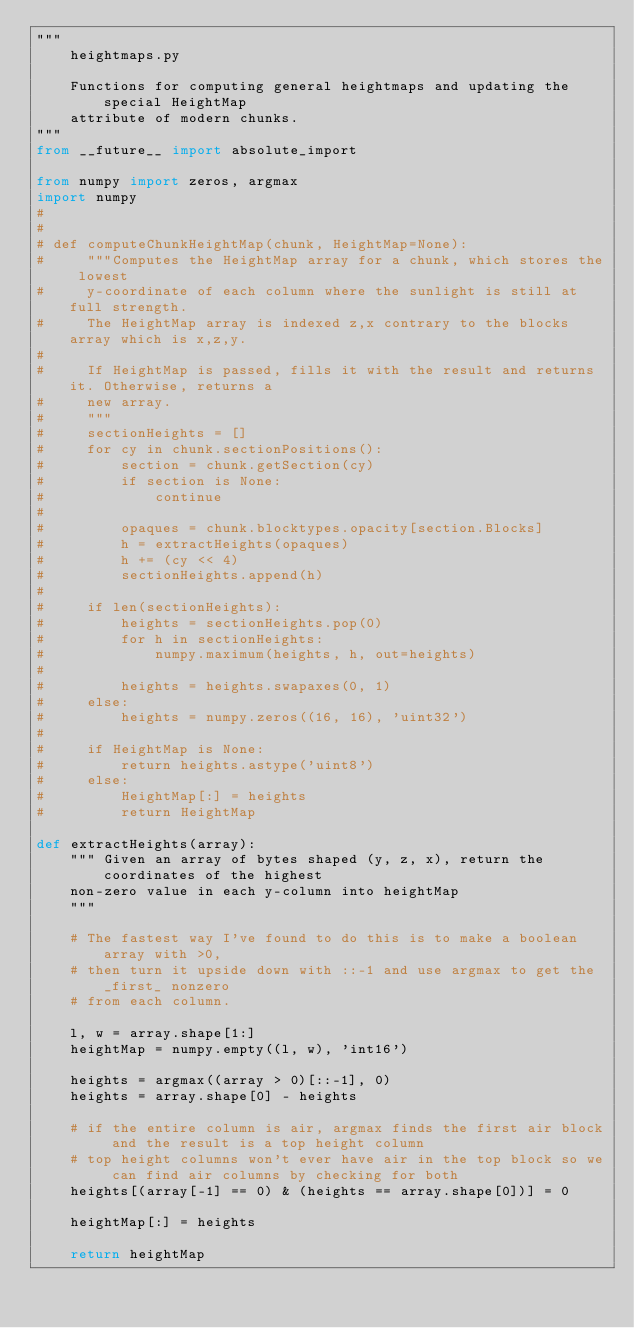<code> <loc_0><loc_0><loc_500><loc_500><_Python_>"""
    heightmaps.py

    Functions for computing general heightmaps and updating the special HeightMap
    attribute of modern chunks.
"""
from __future__ import absolute_import

from numpy import zeros, argmax
import numpy
#
#
# def computeChunkHeightMap(chunk, HeightMap=None):
#     """Computes the HeightMap array for a chunk, which stores the lowest
#     y-coordinate of each column where the sunlight is still at full strength.
#     The HeightMap array is indexed z,x contrary to the blocks array which is x,z,y.
#
#     If HeightMap is passed, fills it with the result and returns it. Otherwise, returns a
#     new array.
#     """
#     sectionHeights = []
#     for cy in chunk.sectionPositions():
#         section = chunk.getSection(cy)
#         if section is None:
#             continue
#
#         opaques = chunk.blocktypes.opacity[section.Blocks]
#         h = extractHeights(opaques)
#         h += (cy << 4)
#         sectionHeights.append(h)
#
#     if len(sectionHeights):
#         heights = sectionHeights.pop(0)
#         for h in sectionHeights:
#             numpy.maximum(heights, h, out=heights)
#
#         heights = heights.swapaxes(0, 1)
#     else:
#         heights = numpy.zeros((16, 16), 'uint32')
#
#     if HeightMap is None:
#         return heights.astype('uint8')
#     else:
#         HeightMap[:] = heights
#         return HeightMap

def extractHeights(array):
    """ Given an array of bytes shaped (y, z, x), return the coordinates of the highest
    non-zero value in each y-column into heightMap
    """

    # The fastest way I've found to do this is to make a boolean array with >0,
    # then turn it upside down with ::-1 and use argmax to get the _first_ nonzero
    # from each column.

    l, w = array.shape[1:]
    heightMap = numpy.empty((l, w), 'int16')

    heights = argmax((array > 0)[::-1], 0)
    heights = array.shape[0] - heights

    # if the entire column is air, argmax finds the first air block and the result is a top height column
    # top height columns won't ever have air in the top block so we can find air columns by checking for both
    heights[(array[-1] == 0) & (heights == array.shape[0])] = 0

    heightMap[:] = heights

    return heightMap
</code> 